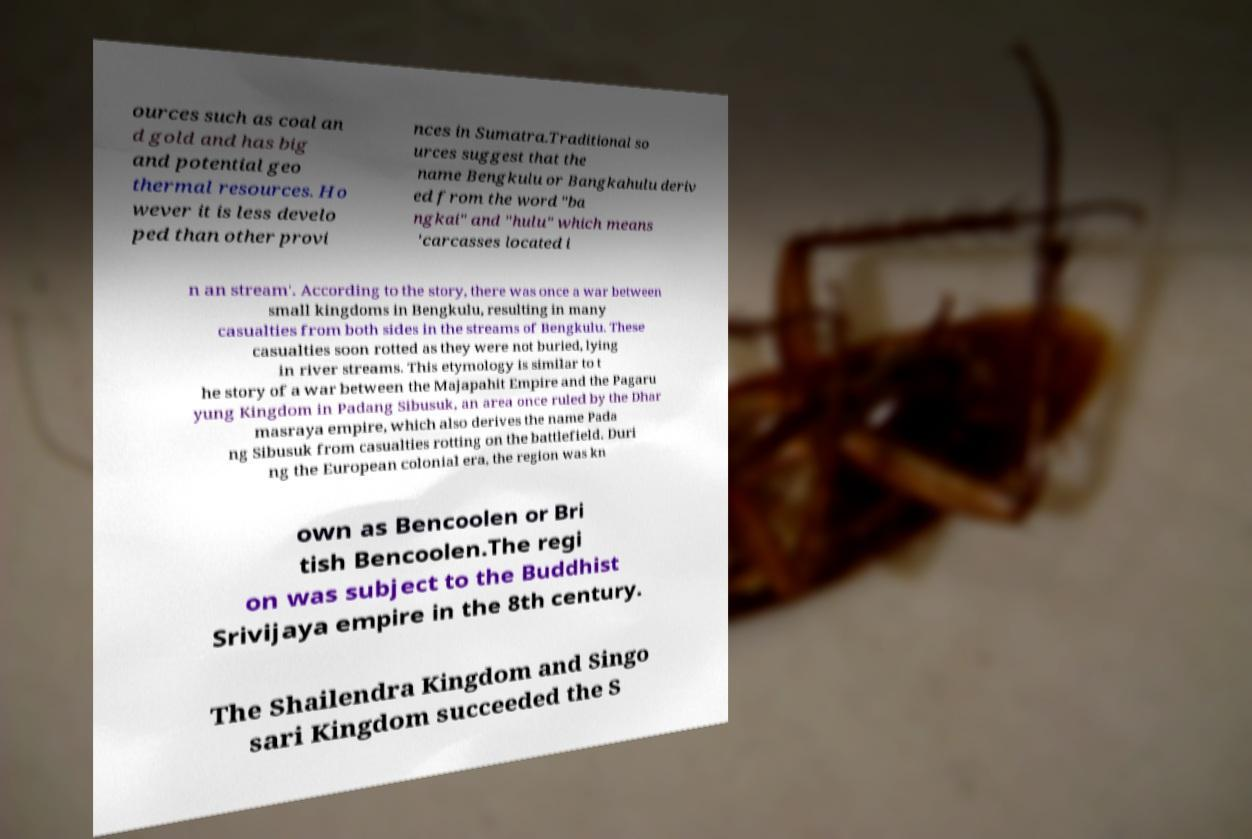There's text embedded in this image that I need extracted. Can you transcribe it verbatim? ources such as coal an d gold and has big and potential geo thermal resources. Ho wever it is less develo ped than other provi nces in Sumatra.Traditional so urces suggest that the name Bengkulu or Bangkahulu deriv ed from the word "ba ngkai" and "hulu" which means 'carcasses located i n an stream'. According to the story, there was once a war between small kingdoms in Bengkulu, resulting in many casualties from both sides in the streams of Bengkulu. These casualties soon rotted as they were not buried, lying in river streams. This etymology is similar to t he story of a war between the Majapahit Empire and the Pagaru yung Kingdom in Padang Sibusuk, an area once ruled by the Dhar masraya empire, which also derives the name Pada ng Sibusuk from casualties rotting on the battlefield. Duri ng the European colonial era, the region was kn own as Bencoolen or Bri tish Bencoolen.The regi on was subject to the Buddhist Srivijaya empire in the 8th century. The Shailendra Kingdom and Singo sari Kingdom succeeded the S 